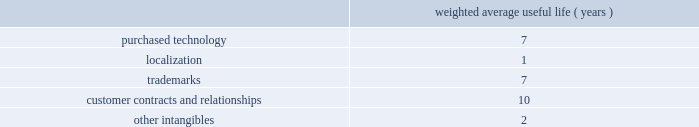Adobe systems incorporated notes to consolidated financial statements ( continued ) foreign currency translation we translate assets and liabilities of foreign subsidiaries , whose functional currency is their local currency , at exchange rates in effect at the balance sheet date .
We translate revenue and expenses at the monthly average exchange rates .
We include accumulated net translation adjustments in stockholders 2019 equity as a component of accumulated other comprehensive income .
Property and equipment we record property and equipment at cost less accumulated depreciation and amortization .
Property and equipment are depreciated using the straight-line method over their estimated useful lives ranging from 1 to 5 years for computers and equipment , 1 to 6 years for furniture and fixtures and up to 35 years for buildings .
Leasehold improvements are amortized using the straight-line method over the lesser of the remaining respective lease term or useful lives .
Goodwill , purchased intangibles and other long-lived assets we review our goodwill for impairment annually , or more frequently , if facts and circumstances warrant a review .
We completed our annual impairment test in the second quarter of fiscal 2009 and determined that there was no impairment .
Goodwill is assigned to one or more reporting segments on the date of acquisition .
We evaluate goodwill for impairment by comparing the fair value of each of our reporting segments to its carrying value , including the associated goodwill .
To determine the fair values , we use the market approach based on comparable publicly traded companies in similar lines of businesses and the income approach based on estimated discounted future cash flows .
Our cash flow assumptions consider historical and forecasted revenue , operating costs and other relevant factors .
We amortize intangible assets with finite lives over their estimated useful lives and review them for impairment whenever an impairment indicator exists .
We continually monitor events and changes in circumstances that could indicate carrying amounts of our long-lived assets , including our intangible assets may not be recoverable .
When such events or changes in circumstances occur , we assess recoverability by determining whether the carrying value of such assets will be recovered through the undiscounted expected future cash flows .
If the future undiscounted cash flows are less than the carrying amount of these assets , we recognize an impairment loss based on the excess of the carrying amount over the fair value of the assets .
We did not recognize any intangible asset impairment charges in fiscal 2009 , 2008 or 2007 .
Our intangible assets are amortized over their estimated useful lives of 1 to 13 years as shown in the table below .
Amortization is based on the pattern in which the economic benefits of the intangible asset will be consumed .
Weighted average useful life ( years ) .
Software development costs capitalization of software development costs for software to be sold , leased , or otherwise marketed begins upon the establishment of technological feasibility , which is generally the completion of a working prototype that has been certified as having no critical bugs and is a release candidate .
Amortization begins once the software is ready for its intended use , generally based on the pattern in which the economic benefits will be consumed .
To date , software development costs incurred between completion of a working prototype and general availability of the related product have not been material .
Revenue recognition our revenue is derived from the licensing of software products , consulting , hosting services and maintenance and support .
Primarily , we recognize revenue when persuasive evidence of an arrangement exists , we have delivered the product or performed the service , the fee is fixed or determinable and collection is probable. .
What is the yearly amortization rate related to the purchased technology? 
Computations: (100 / 7)
Answer: 14.28571. Adobe systems incorporated notes to consolidated financial statements ( continued ) foreign currency translation we translate assets and liabilities of foreign subsidiaries , whose functional currency is their local currency , at exchange rates in effect at the balance sheet date .
We translate revenue and expenses at the monthly average exchange rates .
We include accumulated net translation adjustments in stockholders 2019 equity as a component of accumulated other comprehensive income .
Property and equipment we record property and equipment at cost less accumulated depreciation and amortization .
Property and equipment are depreciated using the straight-line method over their estimated useful lives ranging from 1 to 5 years for computers and equipment , 1 to 6 years for furniture and fixtures and up to 35 years for buildings .
Leasehold improvements are amortized using the straight-line method over the lesser of the remaining respective lease term or useful lives .
Goodwill , purchased intangibles and other long-lived assets we review our goodwill for impairment annually , or more frequently , if facts and circumstances warrant a review .
We completed our annual impairment test in the second quarter of fiscal 2009 and determined that there was no impairment .
Goodwill is assigned to one or more reporting segments on the date of acquisition .
We evaluate goodwill for impairment by comparing the fair value of each of our reporting segments to its carrying value , including the associated goodwill .
To determine the fair values , we use the market approach based on comparable publicly traded companies in similar lines of businesses and the income approach based on estimated discounted future cash flows .
Our cash flow assumptions consider historical and forecasted revenue , operating costs and other relevant factors .
We amortize intangible assets with finite lives over their estimated useful lives and review them for impairment whenever an impairment indicator exists .
We continually monitor events and changes in circumstances that could indicate carrying amounts of our long-lived assets , including our intangible assets may not be recoverable .
When such events or changes in circumstances occur , we assess recoverability by determining whether the carrying value of such assets will be recovered through the undiscounted expected future cash flows .
If the future undiscounted cash flows are less than the carrying amount of these assets , we recognize an impairment loss based on the excess of the carrying amount over the fair value of the assets .
We did not recognize any intangible asset impairment charges in fiscal 2009 , 2008 or 2007 .
Our intangible assets are amortized over their estimated useful lives of 1 to 13 years as shown in the table below .
Amortization is based on the pattern in which the economic benefits of the intangible asset will be consumed .
Weighted average useful life ( years ) .
Software development costs capitalization of software development costs for software to be sold , leased , or otherwise marketed begins upon the establishment of technological feasibility , which is generally the completion of a working prototype that has been certified as having no critical bugs and is a release candidate .
Amortization begins once the software is ready for its intended use , generally based on the pattern in which the economic benefits will be consumed .
To date , software development costs incurred between completion of a working prototype and general availability of the related product have not been material .
Revenue recognition our revenue is derived from the licensing of software products , consulting , hosting services and maintenance and support .
Primarily , we recognize revenue when persuasive evidence of an arrangement exists , we have delivered the product or performed the service , the fee is fixed or determinable and collection is probable. .
What is the yearly amortization rate related to trademarks? 
Computations: (100 / 7)
Answer: 14.28571. 